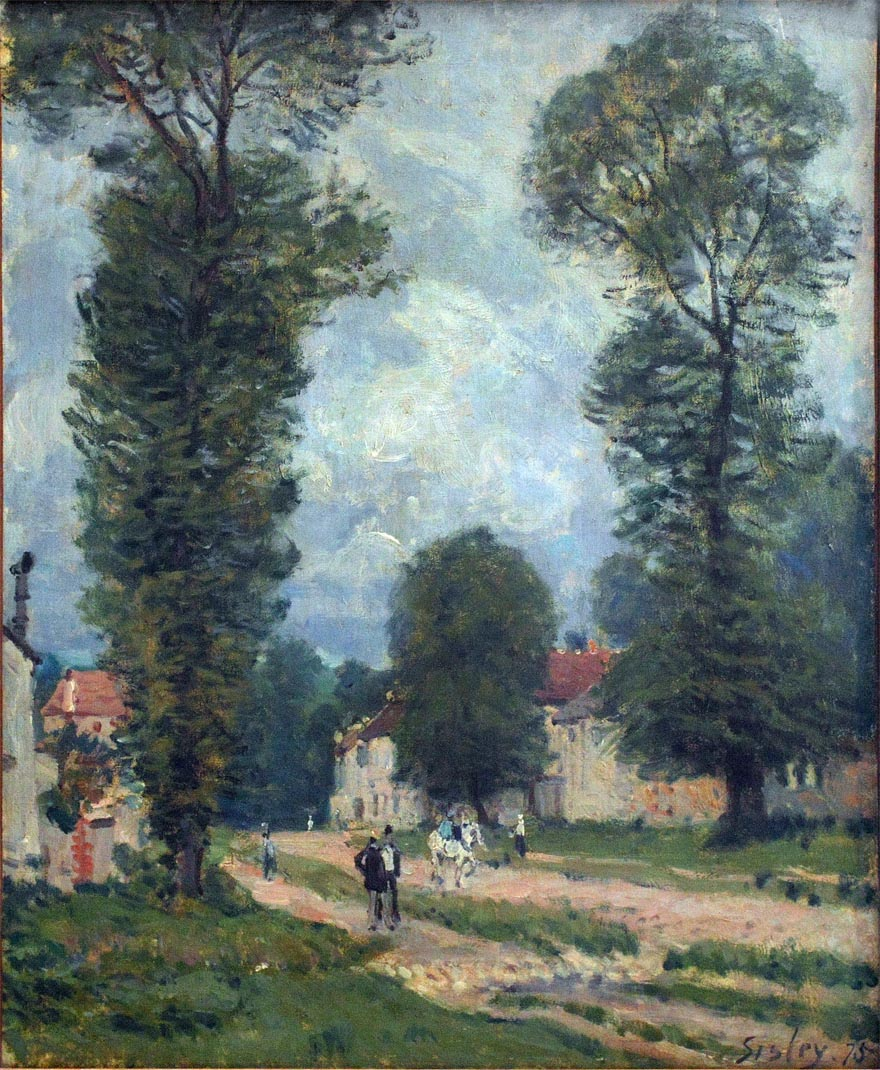Imagine the day this scene was painted. What might people in the scene be talking about? On the day this scene was painted, one can imagine the conversations being light-hearted and reflective of daily rural life. The man on horseback might be discussing agricultural plans and weather with nearby villagers. The group walking together could be sharing stories of their day, discussing local happenings, or perhaps planning an evening gathering. The tranquil setting hints at a close-knit community, where interactions are warm and personal. What do you think about the mood of the painting? The mood of the painting is serene and pastoral, radiating tranquility and simplicity. The blending of colors and loose brushwork typical of impressionism conveys a relaxed and unhurried atmosphere. The villagers appear to be leisurely going about their day, adding to the overall sense of peace and contentment in this rural setting. The pale, soft-blue sky with gentle clouds further enhances this calm and soothing mood, making the viewer feel at ease and connect with the simplicity of rural life. 